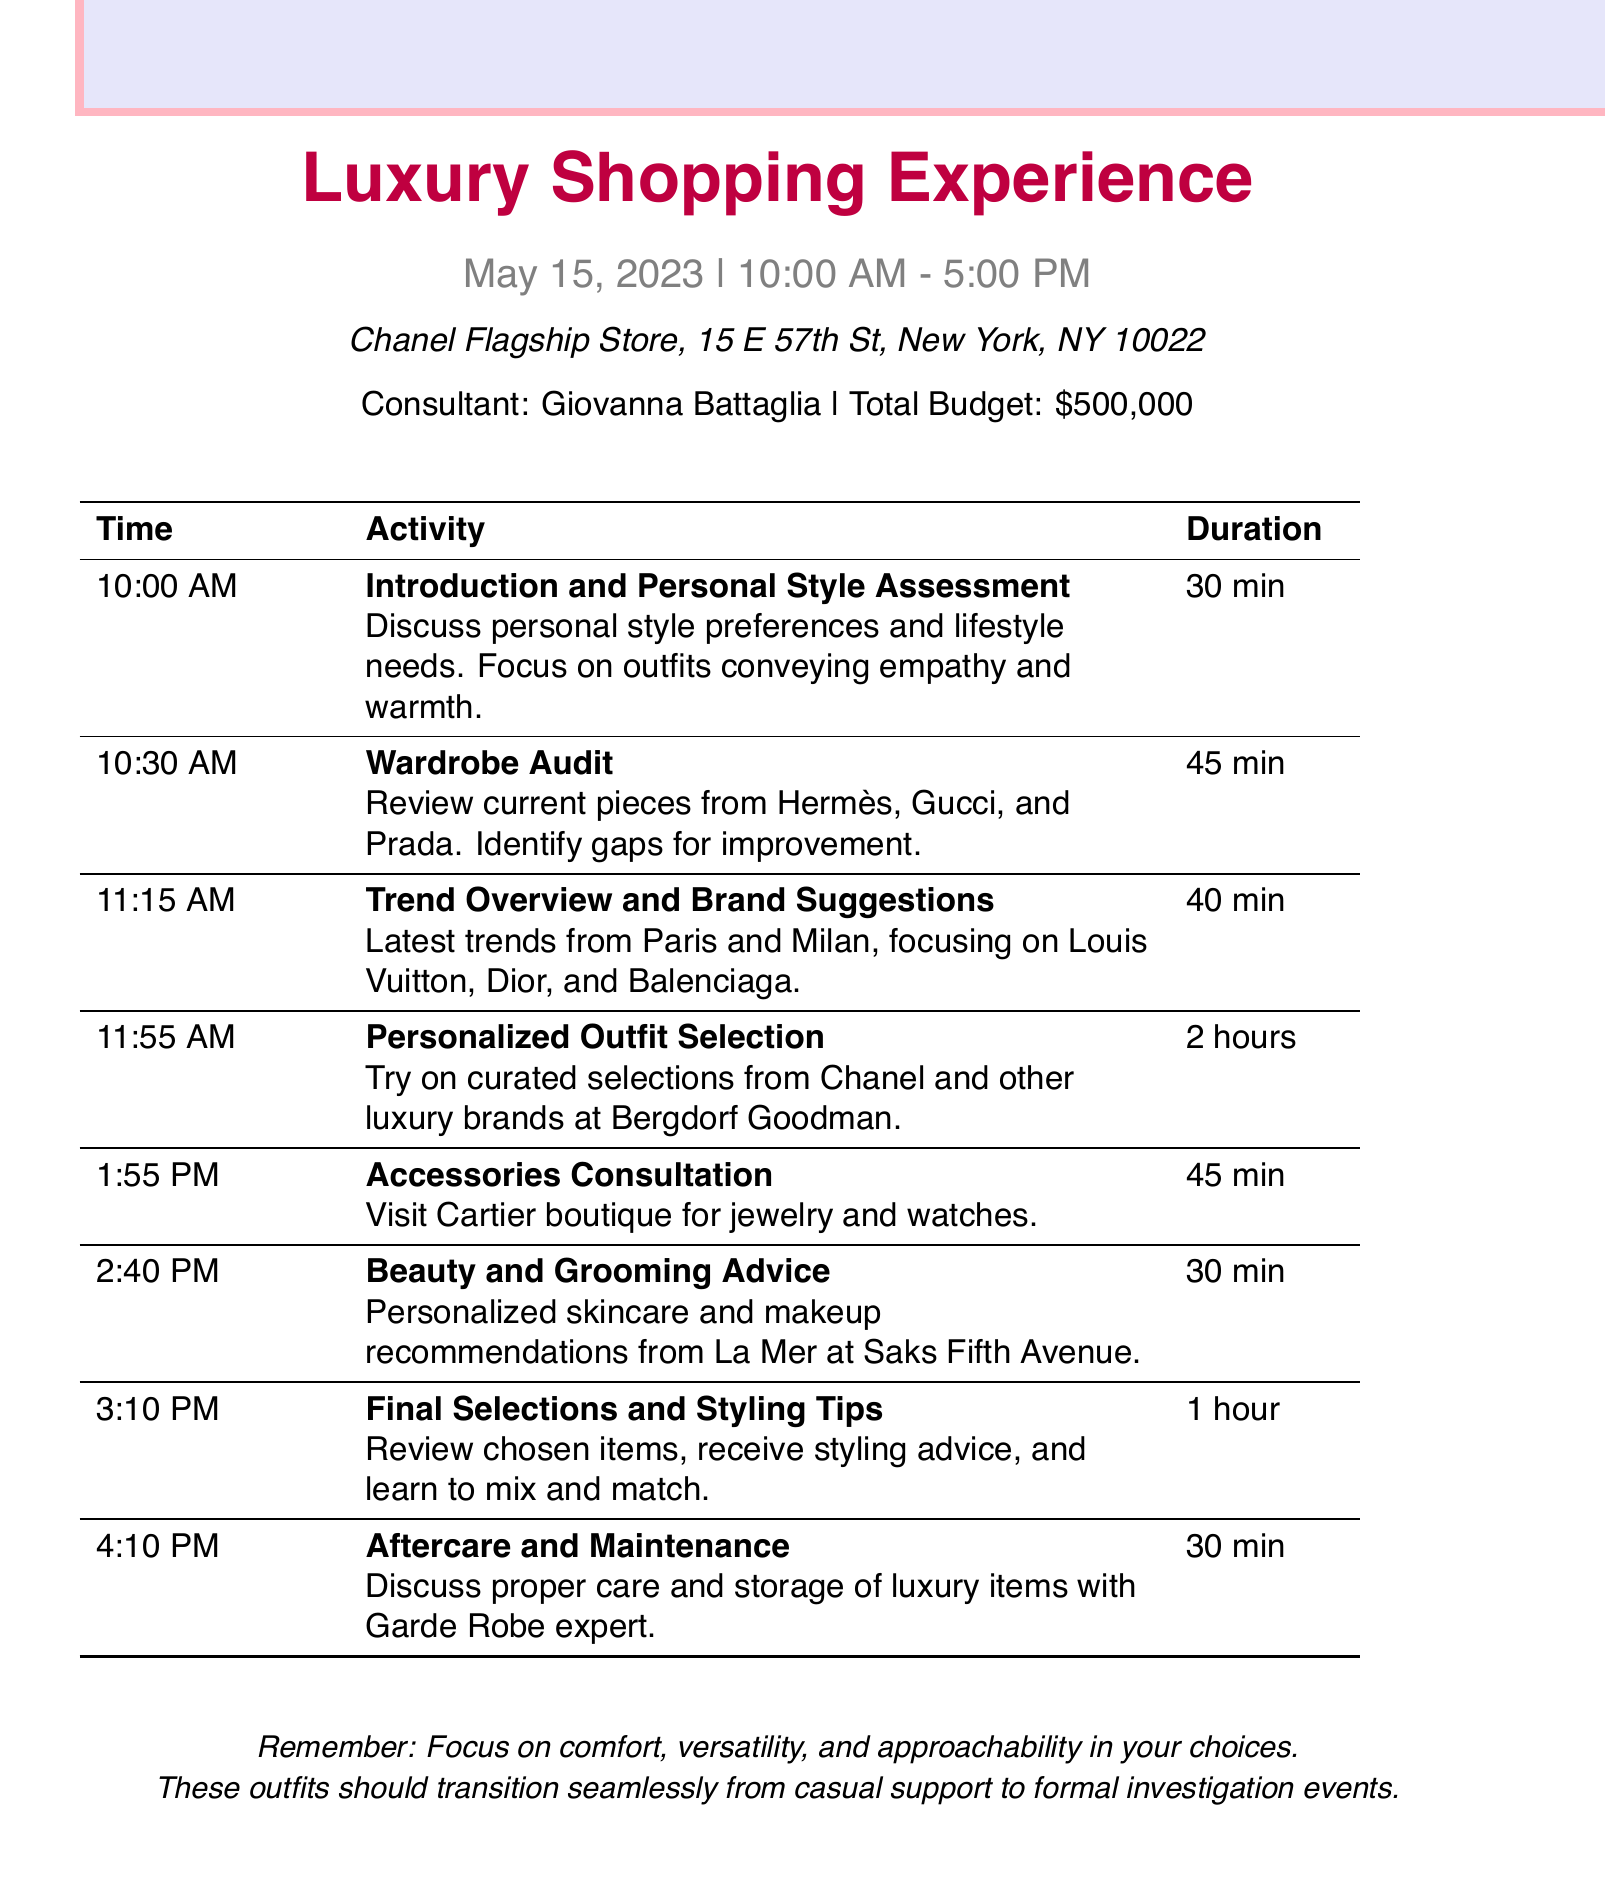What is the date of the appointment? The date is mentioned in the logistics section of the document.
Answer: May 15, 2023 Who is the fashion consultant? The consultant's name is listed at the end of the introductory section.
Answer: Giovanna Battaglia What time does the appointment start? The start time is indicated in the logistics details.
Answer: 10:00 AM How long is the personalized outfit selection segment? The duration for this activity is specified in the agenda items.
Answer: 2 hours What brands are highlighted during the wardrobe audit? The brands are mentioned in the description of the wardrobe audit activity.
Answer: Hermès, Gucci, and Prada What is the total budget for the shopping experience? The total budget is stated in the logistics section.
Answer: $500,000 Which boutique will be visited for accessories consultation? The boutique name is included in the accessories consultation description.
Answer: Cartier What is the primary focus of the beauty and grooming advice session? The main focus is outlined in the description for that agenda item.
Answer: Personalized skincare and makeup recommendations How many total agenda items are listed in the document? The number of agenda items can be counted from the provided sections.
Answer: 8 